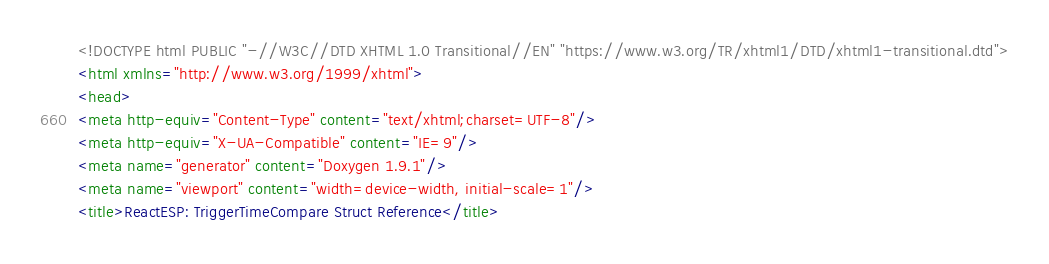Convert code to text. <code><loc_0><loc_0><loc_500><loc_500><_HTML_><!DOCTYPE html PUBLIC "-//W3C//DTD XHTML 1.0 Transitional//EN" "https://www.w3.org/TR/xhtml1/DTD/xhtml1-transitional.dtd">
<html xmlns="http://www.w3.org/1999/xhtml">
<head>
<meta http-equiv="Content-Type" content="text/xhtml;charset=UTF-8"/>
<meta http-equiv="X-UA-Compatible" content="IE=9"/>
<meta name="generator" content="Doxygen 1.9.1"/>
<meta name="viewport" content="width=device-width, initial-scale=1"/>
<title>ReactESP: TriggerTimeCompare Struct Reference</title></code> 